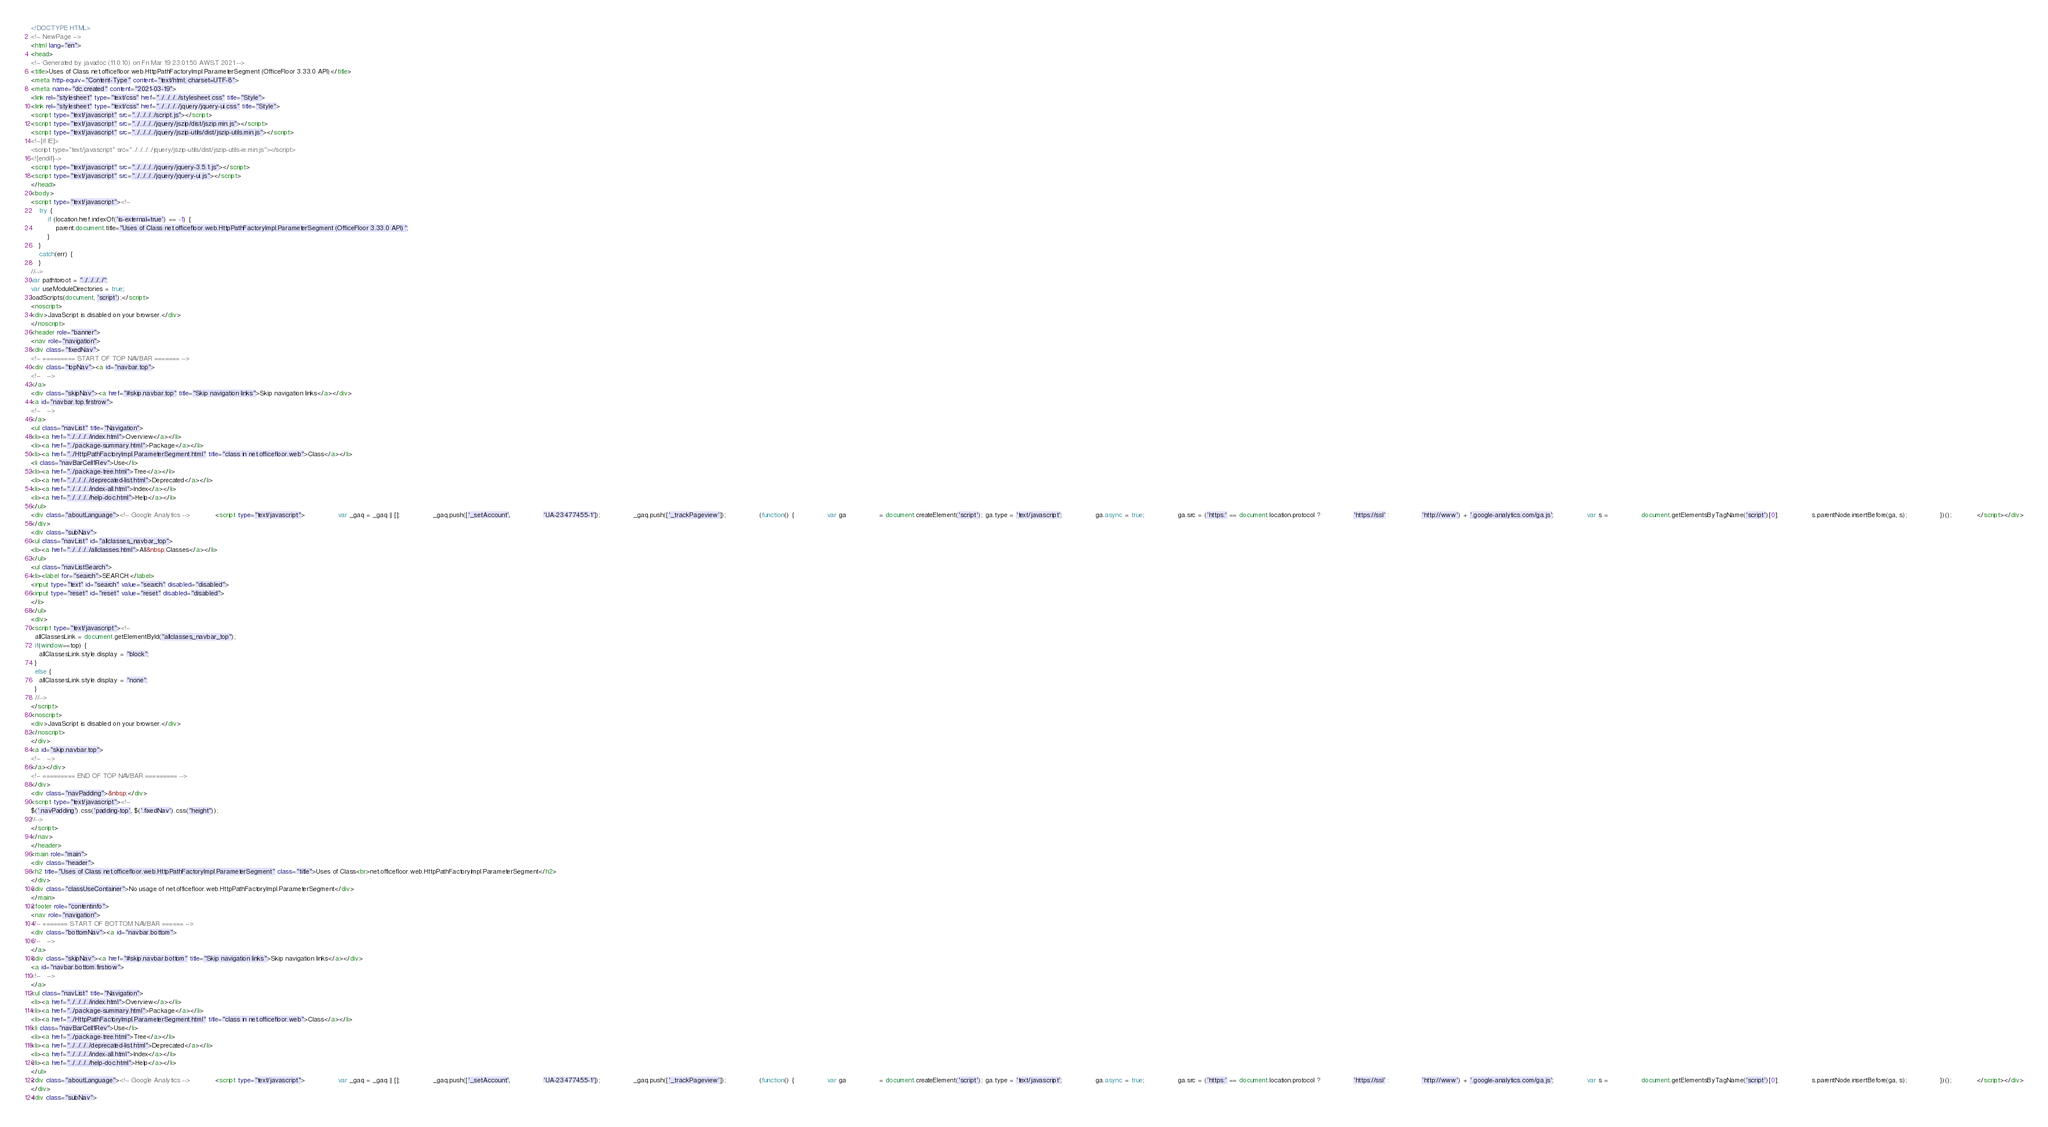Convert code to text. <code><loc_0><loc_0><loc_500><loc_500><_HTML_><!DOCTYPE HTML>
<!-- NewPage -->
<html lang="en">
<head>
<!-- Generated by javadoc (11.0.10) on Fri Mar 19 23:01:50 AWST 2021 -->
<title>Uses of Class net.officefloor.web.HttpPathFactoryImpl.ParameterSegment (OfficeFloor 3.33.0 API)</title>
<meta http-equiv="Content-Type" content="text/html; charset=UTF-8">
<meta name="dc.created" content="2021-03-19">
<link rel="stylesheet" type="text/css" href="../../../../stylesheet.css" title="Style">
<link rel="stylesheet" type="text/css" href="../../../../jquery/jquery-ui.css" title="Style">
<script type="text/javascript" src="../../../../script.js"></script>
<script type="text/javascript" src="../../../../jquery/jszip/dist/jszip.min.js"></script>
<script type="text/javascript" src="../../../../jquery/jszip-utils/dist/jszip-utils.min.js"></script>
<!--[if IE]>
<script type="text/javascript" src="../../../../jquery/jszip-utils/dist/jszip-utils-ie.min.js"></script>
<![endif]-->
<script type="text/javascript" src="../../../../jquery/jquery-3.5.1.js"></script>
<script type="text/javascript" src="../../../../jquery/jquery-ui.js"></script>
</head>
<body>
<script type="text/javascript"><!--
    try {
        if (location.href.indexOf('is-external=true') == -1) {
            parent.document.title="Uses of Class net.officefloor.web.HttpPathFactoryImpl.ParameterSegment (OfficeFloor 3.33.0 API)";
        }
    }
    catch(err) {
    }
//-->
var pathtoroot = "../../../../";
var useModuleDirectories = true;
loadScripts(document, 'script');</script>
<noscript>
<div>JavaScript is disabled on your browser.</div>
</noscript>
<header role="banner">
<nav role="navigation">
<div class="fixedNav">
<!-- ========= START OF TOP NAVBAR ======= -->
<div class="topNav"><a id="navbar.top">
<!--   -->
</a>
<div class="skipNav"><a href="#skip.navbar.top" title="Skip navigation links">Skip navigation links</a></div>
<a id="navbar.top.firstrow">
<!--   -->
</a>
<ul class="navList" title="Navigation">
<li><a href="../../../../index.html">Overview</a></li>
<li><a href="../package-summary.html">Package</a></li>
<li><a href="../HttpPathFactoryImpl.ParameterSegment.html" title="class in net.officefloor.web">Class</a></li>
<li class="navBarCell1Rev">Use</li>
<li><a href="../package-tree.html">Tree</a></li>
<li><a href="../../../../deprecated-list.html">Deprecated</a></li>
<li><a href="../../../../index-all.html">Index</a></li>
<li><a href="../../../../help-doc.html">Help</a></li>
</ul>
<div class="aboutLanguage"><!-- Google Analytics --> 			<script type="text/javascript"> 				var _gaq = _gaq || []; 				_gaq.push(['_setAccount', 				'UA-23477455-1']); 				_gaq.push(['_trackPageview']);  				(function() { 				var ga 				= document.createElement('script'); ga.type = 'text/javascript'; 				ga.async = true; 				ga.src = ('https:' == document.location.protocol ? 				'https://ssl' : 				'http://www') + '.google-analytics.com/ga.js'; 				var s = 				document.getElementsByTagName('script')[0]; 				s.parentNode.insertBefore(ga, s); 				})(); 			</script></div>
</div>
<div class="subNav">
<ul class="navList" id="allclasses_navbar_top">
<li><a href="../../../../allclasses.html">All&nbsp;Classes</a></li>
</ul>
<ul class="navListSearch">
<li><label for="search">SEARCH:</label>
<input type="text" id="search" value="search" disabled="disabled">
<input type="reset" id="reset" value="reset" disabled="disabled">
</li>
</ul>
<div>
<script type="text/javascript"><!--
  allClassesLink = document.getElementById("allclasses_navbar_top");
  if(window==top) {
    allClassesLink.style.display = "block";
  }
  else {
    allClassesLink.style.display = "none";
  }
  //-->
</script>
<noscript>
<div>JavaScript is disabled on your browser.</div>
</noscript>
</div>
<a id="skip.navbar.top">
<!--   -->
</a></div>
<!-- ========= END OF TOP NAVBAR ========= -->
</div>
<div class="navPadding">&nbsp;</div>
<script type="text/javascript"><!--
$('.navPadding').css('padding-top', $('.fixedNav').css("height"));
//-->
</script>
</nav>
</header>
<main role="main">
<div class="header">
<h2 title="Uses of Class net.officefloor.web.HttpPathFactoryImpl.ParameterSegment" class="title">Uses of Class<br>net.officefloor.web.HttpPathFactoryImpl.ParameterSegment</h2>
</div>
<div class="classUseContainer">No usage of net.officefloor.web.HttpPathFactoryImpl.ParameterSegment</div>
</main>
<footer role="contentinfo">
<nav role="navigation">
<!-- ======= START OF BOTTOM NAVBAR ====== -->
<div class="bottomNav"><a id="navbar.bottom">
<!--   -->
</a>
<div class="skipNav"><a href="#skip.navbar.bottom" title="Skip navigation links">Skip navigation links</a></div>
<a id="navbar.bottom.firstrow">
<!--   -->
</a>
<ul class="navList" title="Navigation">
<li><a href="../../../../index.html">Overview</a></li>
<li><a href="../package-summary.html">Package</a></li>
<li><a href="../HttpPathFactoryImpl.ParameterSegment.html" title="class in net.officefloor.web">Class</a></li>
<li class="navBarCell1Rev">Use</li>
<li><a href="../package-tree.html">Tree</a></li>
<li><a href="../../../../deprecated-list.html">Deprecated</a></li>
<li><a href="../../../../index-all.html">Index</a></li>
<li><a href="../../../../help-doc.html">Help</a></li>
</ul>
<div class="aboutLanguage"><!-- Google Analytics --> 			<script type="text/javascript"> 				var _gaq = _gaq || []; 				_gaq.push(['_setAccount', 				'UA-23477455-1']); 				_gaq.push(['_trackPageview']);  				(function() { 				var ga 				= document.createElement('script'); ga.type = 'text/javascript'; 				ga.async = true; 				ga.src = ('https:' == document.location.protocol ? 				'https://ssl' : 				'http://www') + '.google-analytics.com/ga.js'; 				var s = 				document.getElementsByTagName('script')[0]; 				s.parentNode.insertBefore(ga, s); 				})(); 			</script></div>
</div>
<div class="subNav"></code> 